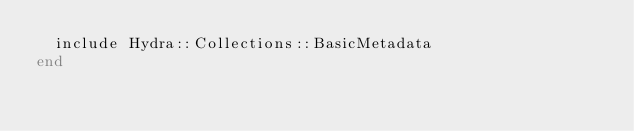Convert code to text. <code><loc_0><loc_0><loc_500><loc_500><_Ruby_>  include Hydra::Collections::BasicMetadata
end
</code> 